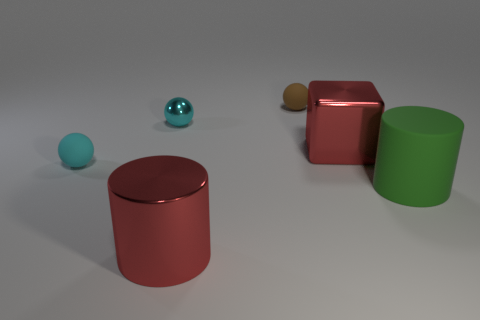Add 2 green shiny things. How many objects exist? 8 Subtract all cyan balls. How many balls are left? 1 Subtract all blocks. How many objects are left? 5 Subtract 1 blocks. How many blocks are left? 0 Subtract all brown spheres. How many spheres are left? 2 Subtract 0 gray cubes. How many objects are left? 6 Subtract all brown spheres. Subtract all yellow blocks. How many spheres are left? 2 Subtract all purple cubes. How many gray balls are left? 0 Subtract all brown objects. Subtract all rubber cylinders. How many objects are left? 4 Add 4 tiny balls. How many tiny balls are left? 7 